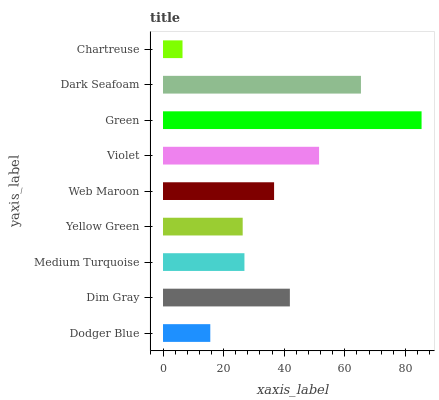Is Chartreuse the minimum?
Answer yes or no. Yes. Is Green the maximum?
Answer yes or no. Yes. Is Dim Gray the minimum?
Answer yes or no. No. Is Dim Gray the maximum?
Answer yes or no. No. Is Dim Gray greater than Dodger Blue?
Answer yes or no. Yes. Is Dodger Blue less than Dim Gray?
Answer yes or no. Yes. Is Dodger Blue greater than Dim Gray?
Answer yes or no. No. Is Dim Gray less than Dodger Blue?
Answer yes or no. No. Is Web Maroon the high median?
Answer yes or no. Yes. Is Web Maroon the low median?
Answer yes or no. Yes. Is Green the high median?
Answer yes or no. No. Is Dodger Blue the low median?
Answer yes or no. No. 